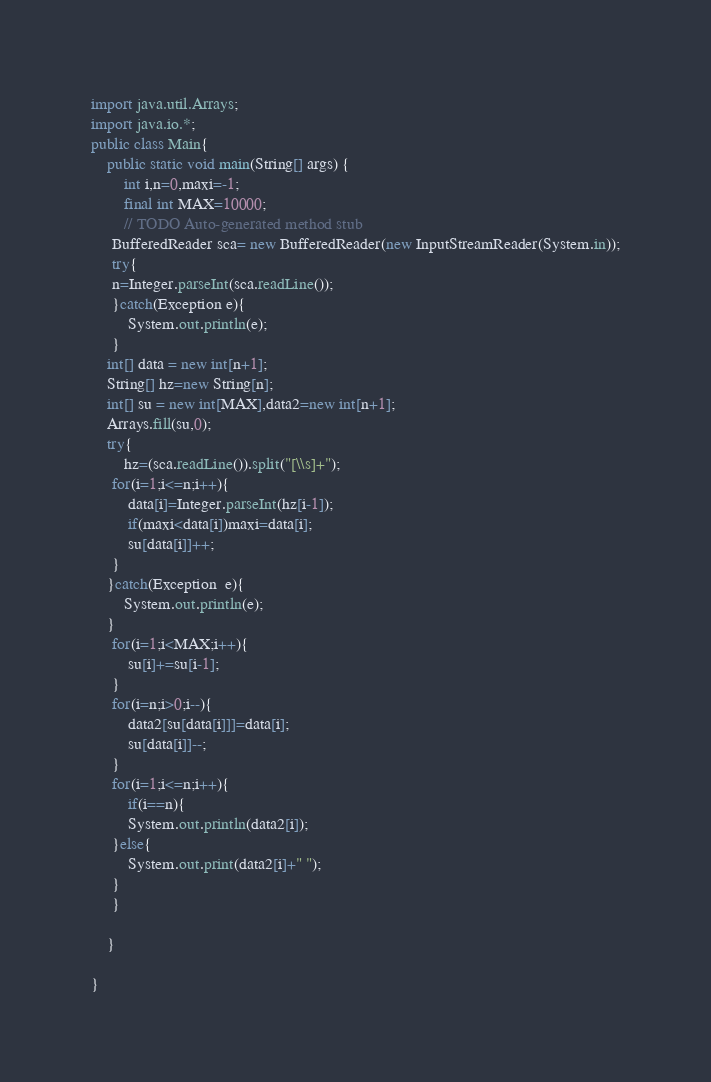<code> <loc_0><loc_0><loc_500><loc_500><_Java_>import java.util.Arrays;
import java.io.*;
public class Main{
	public static void main(String[] args) {
		int i,n=0,maxi=-1;
		final int MAX=10000;
		// TODO Auto-generated method stub
     BufferedReader sca= new BufferedReader(new InputStreamReader(System.in));
     try{
     n=Integer.parseInt(sca.readLine());
     }catch(Exception e){
    	 System.out.println(e);
     }
    int[] data = new int[n+1];
    String[] hz=new String[n];
    int[] su = new int[MAX],data2=new int[n+1];
    Arrays.fill(su,0);
    try{
    	hz=(sca.readLine()).split("[\\s]+");
     for(i=1;i<=n;i++){
    	 data[i]=Integer.parseInt(hz[i-1]);
    	 if(maxi<data[i])maxi=data[i];
    	 su[data[i]]++;
     }
    }catch(Exception  e){
    	System.out.println(e);
    }
     for(i=1;i<MAX;i++){
    	 su[i]+=su[i-1];
     }
     for(i=n;i>0;i--){
    	 data2[su[data[i]]]=data[i];
    	 su[data[i]]--;
     }
     for(i=1;i<=n;i++){
    	 if(i==n){
    	 System.out.println(data2[i]);
     }else{
    	 System.out.print(data2[i]+" ");
     }
     }
     
	}

}
</code> 